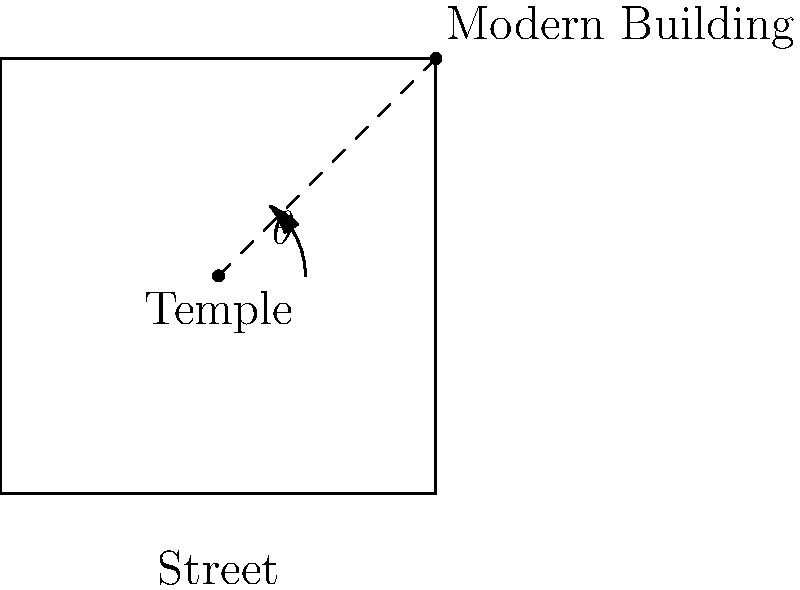In the diagram, a Taoist temple is positioned at point E, with a modern building at point C. The optimal angle $\theta$ for the temple's entrance should face away from the modern building while aligning with traditional Feng Shui principles. If the angle between the temple and the building is 53°, what should be the angle $\theta$ of the temple's entrance in relation to the street (line AB) to maintain harmony? To determine the optimal angle for the temple's entrance, we need to consider the following steps:

1. Recognize that in Taoist and Feng Shui principles, harmony is often achieved through balance and opposition.

2. The modern building represents yang energy (active, modern), while the temple represents yin energy (passive, traditional).

3. To create balance, the temple's entrance should face away from the modern building, creating a 180° opposition.

4. Given:
   - The angle between the temple and the building is 53°
   - We want the entrance to face directly opposite the building

5. Calculate the angle $\theta$:
   $$\theta = 180° - 53° = 127°$$

6. This 127° angle represents the optimal position for the temple's entrance in relation to the street (line AB), creating a harmonious balance with the modern building while adhering to traditional Feng Shui principles.
Answer: 127° 